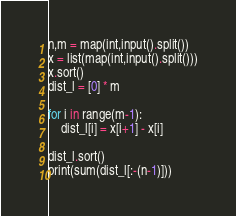<code> <loc_0><loc_0><loc_500><loc_500><_Python_>n,m = map(int,input().split())
x = list(map(int,input().split()))
x.sort()
dist_l = [0] * m

for i in range(m-1):
    dist_l[i] = x[i+1] - x[i]

dist_l.sort()
print(sum(dist_l[:-(n-1)]))</code> 